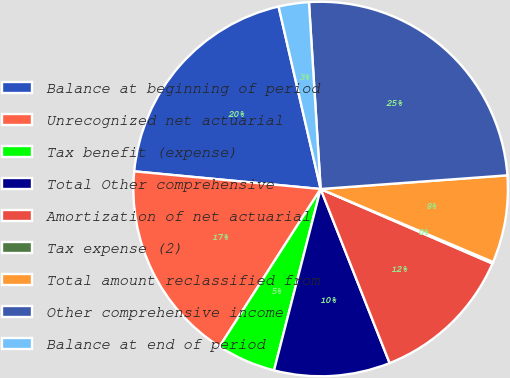Convert chart. <chart><loc_0><loc_0><loc_500><loc_500><pie_chart><fcel>Balance at beginning of period<fcel>Unrecognized net actuarial<fcel>Tax benefit (expense)<fcel>Total Other comprehensive<fcel>Amortization of net actuarial<fcel>Tax expense (2)<fcel>Total amount reclassified from<fcel>Other comprehensive income<fcel>Balance at end of period<nl><fcel>19.89%<fcel>17.42%<fcel>5.08%<fcel>10.01%<fcel>12.48%<fcel>0.14%<fcel>7.54%<fcel>24.83%<fcel>2.61%<nl></chart> 